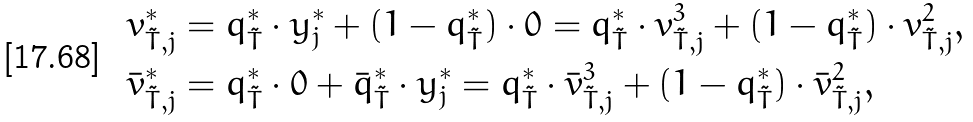Convert formula to latex. <formula><loc_0><loc_0><loc_500><loc_500>& v ^ { * } _ { \tilde { T } , j } = q ^ { * } _ { \tilde { T } } \cdot y ^ { * } _ { j } + ( 1 - q ^ { * } _ { \tilde { T } } ) \cdot 0 = q ^ { * } _ { \tilde { T } } \cdot v ^ { 3 } _ { \tilde { T } , j } + ( 1 - q ^ { * } _ { \tilde { T } } ) \cdot v ^ { 2 } _ { \tilde { T } , j } , \\ & \bar { v } ^ { * } _ { \tilde { T } , j } = q ^ { * } _ { \tilde { T } } \cdot 0 + \bar { q } ^ { * } _ { \tilde { T } } \cdot y ^ { * } _ { j } = q ^ { * } _ { \tilde { T } } \cdot \bar { v } ^ { 3 } _ { \tilde { T } , j } + ( 1 - q ^ { * } _ { \tilde { T } } ) \cdot \bar { v } ^ { 2 } _ { \tilde { T } , j } ,</formula> 